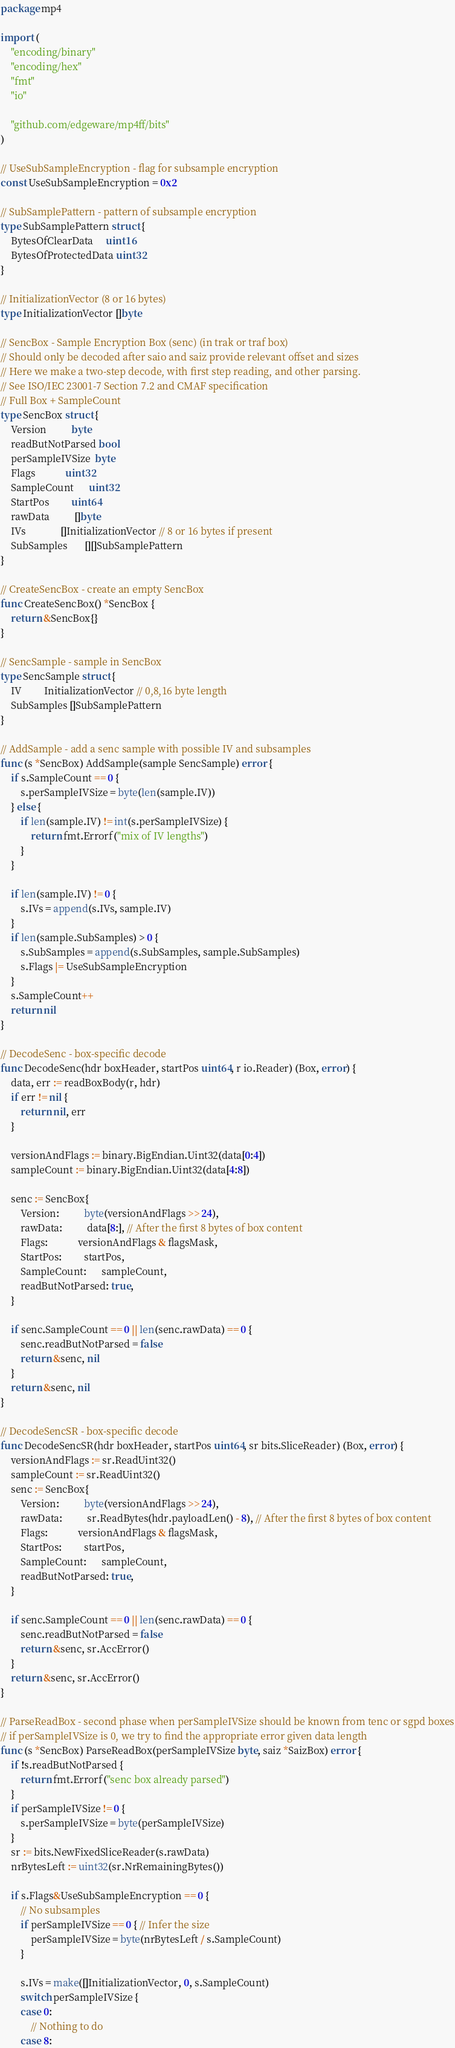<code> <loc_0><loc_0><loc_500><loc_500><_Go_>package mp4

import (
	"encoding/binary"
	"encoding/hex"
	"fmt"
	"io"

	"github.com/edgeware/mp4ff/bits"
)

// UseSubSampleEncryption - flag for subsample encryption
const UseSubSampleEncryption = 0x2

// SubSamplePattern - pattern of subsample encryption
type SubSamplePattern struct {
	BytesOfClearData     uint16
	BytesOfProtectedData uint32
}

// InitializationVector (8 or 16 bytes)
type InitializationVector []byte

// SencBox - Sample Encryption Box (senc) (in trak or traf box)
// Should only be decoded after saio and saiz provide relevant offset and sizes
// Here we make a two-step decode, with first step reading, and other parsing.
// See ISO/IEC 23001-7 Section 7.2 and CMAF specification
// Full Box + SampleCount
type SencBox struct {
	Version          byte
	readButNotParsed bool
	perSampleIVSize  byte
	Flags            uint32
	SampleCount      uint32
	StartPos         uint64
	rawData          []byte
	IVs              []InitializationVector // 8 or 16 bytes if present
	SubSamples       [][]SubSamplePattern
}

// CreateSencBox - create an empty SencBox
func CreateSencBox() *SencBox {
	return &SencBox{}
}

// SencSample - sample in SencBox
type SencSample struct {
	IV         InitializationVector // 0,8,16 byte length
	SubSamples []SubSamplePattern
}

// AddSample - add a senc sample with possible IV and subsamples
func (s *SencBox) AddSample(sample SencSample) error {
	if s.SampleCount == 0 {
		s.perSampleIVSize = byte(len(sample.IV))
	} else {
		if len(sample.IV) != int(s.perSampleIVSize) {
			return fmt.Errorf("mix of IV lengths")
		}
	}

	if len(sample.IV) != 0 {
		s.IVs = append(s.IVs, sample.IV)
	}
	if len(sample.SubSamples) > 0 {
		s.SubSamples = append(s.SubSamples, sample.SubSamples)
		s.Flags |= UseSubSampleEncryption
	}
	s.SampleCount++
	return nil
}

// DecodeSenc - box-specific decode
func DecodeSenc(hdr boxHeader, startPos uint64, r io.Reader) (Box, error) {
	data, err := readBoxBody(r, hdr)
	if err != nil {
		return nil, err
	}

	versionAndFlags := binary.BigEndian.Uint32(data[0:4])
	sampleCount := binary.BigEndian.Uint32(data[4:8])

	senc := SencBox{
		Version:          byte(versionAndFlags >> 24),
		rawData:          data[8:], // After the first 8 bytes of box content
		Flags:            versionAndFlags & flagsMask,
		StartPos:         startPos,
		SampleCount:      sampleCount,
		readButNotParsed: true,
	}

	if senc.SampleCount == 0 || len(senc.rawData) == 0 {
		senc.readButNotParsed = false
		return &senc, nil
	}
	return &senc, nil
}

// DecodeSencSR - box-specific decode
func DecodeSencSR(hdr boxHeader, startPos uint64, sr bits.SliceReader) (Box, error) {
	versionAndFlags := sr.ReadUint32()
	sampleCount := sr.ReadUint32()
	senc := SencBox{
		Version:          byte(versionAndFlags >> 24),
		rawData:          sr.ReadBytes(hdr.payloadLen() - 8), // After the first 8 bytes of box content
		Flags:            versionAndFlags & flagsMask,
		StartPos:         startPos,
		SampleCount:      sampleCount,
		readButNotParsed: true,
	}

	if senc.SampleCount == 0 || len(senc.rawData) == 0 {
		senc.readButNotParsed = false
		return &senc, sr.AccError()
	}
	return &senc, sr.AccError()
}

// ParseReadBox - second phase when perSampleIVSize should be known from tenc or sgpd boxes
// if perSampleIVSize is 0, we try to find the appropriate error given data length
func (s *SencBox) ParseReadBox(perSampleIVSize byte, saiz *SaizBox) error {
	if !s.readButNotParsed {
		return fmt.Errorf("senc box already parsed")
	}
	if perSampleIVSize != 0 {
		s.perSampleIVSize = byte(perSampleIVSize)
	}
	sr := bits.NewFixedSliceReader(s.rawData)
	nrBytesLeft := uint32(sr.NrRemainingBytes())

	if s.Flags&UseSubSampleEncryption == 0 {
		// No subsamples
		if perSampleIVSize == 0 { // Infer the size
			perSampleIVSize = byte(nrBytesLeft / s.SampleCount)
		}

		s.IVs = make([]InitializationVector, 0, s.SampleCount)
		switch perSampleIVSize {
		case 0:
			// Nothing to do
		case 8:</code> 